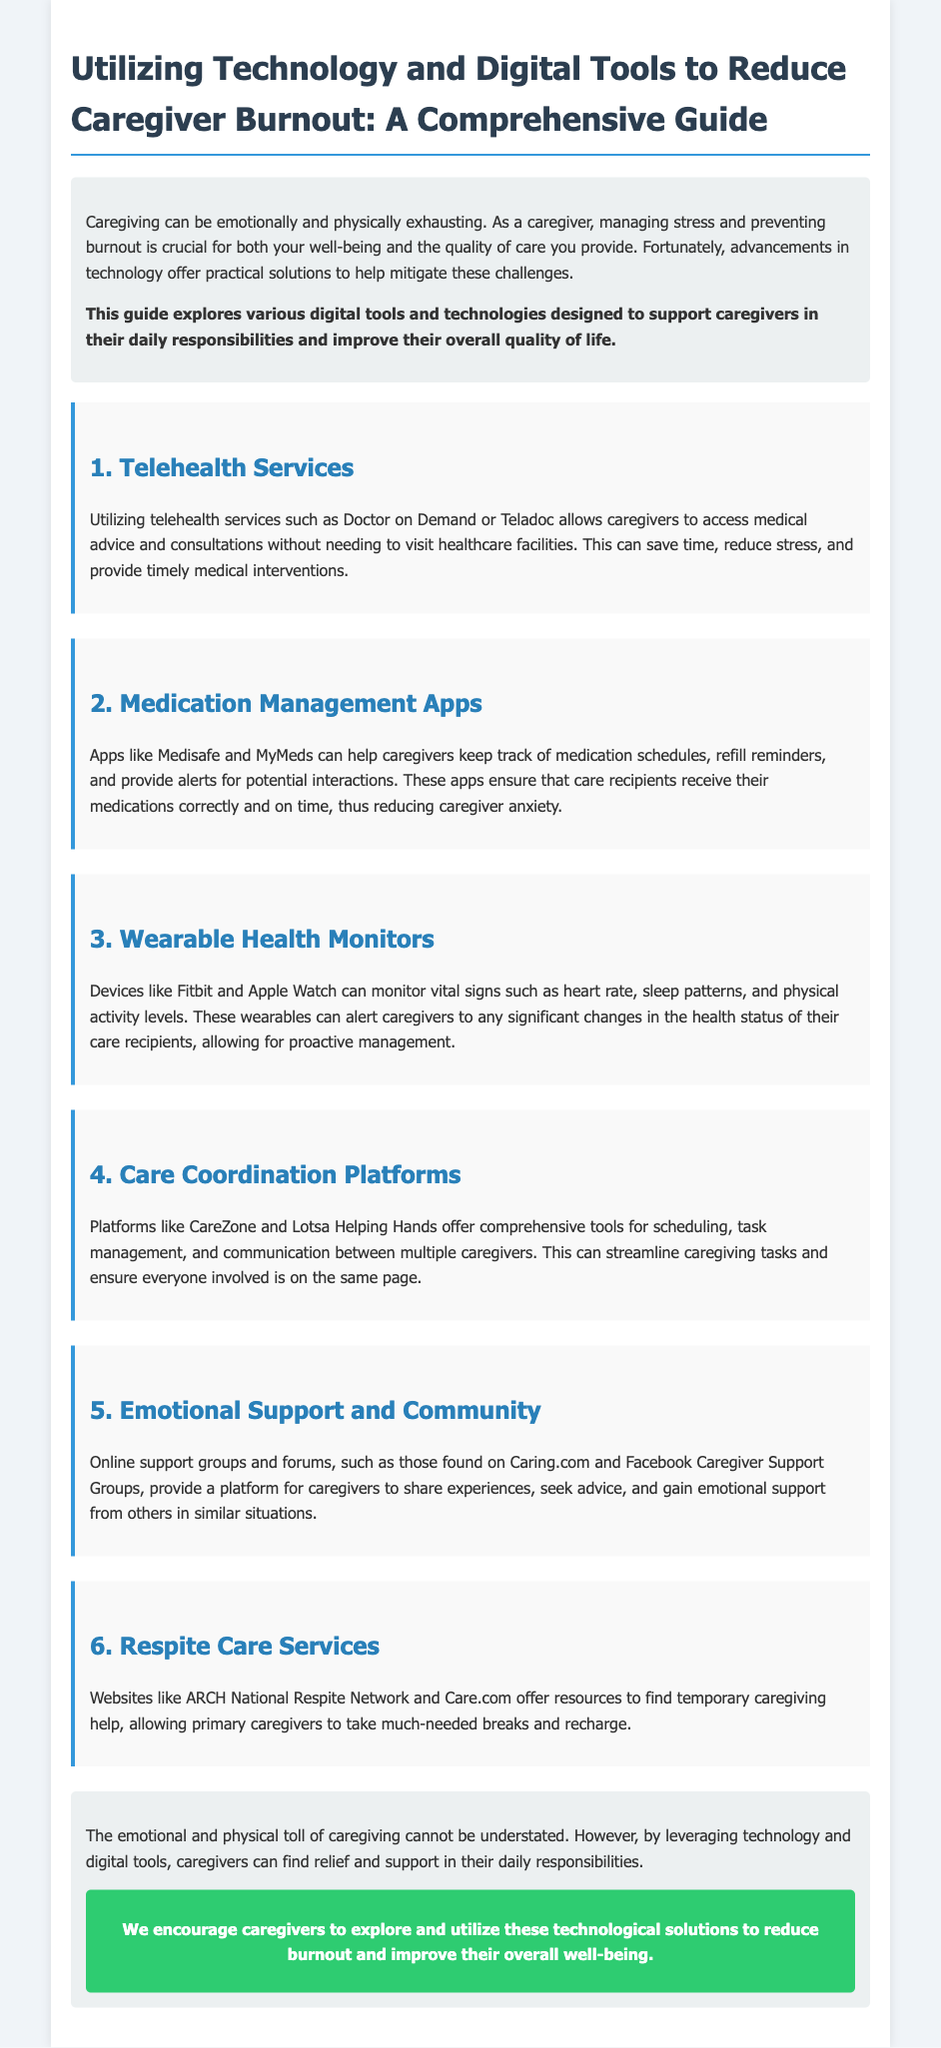What is the title of the document? The title is stated at the top of the document and summarizes the main theme, which is focused on technology and caregivers.
Answer: Utilizing Technology and Digital Tools to Reduce Caregiver Burnout: A Comprehensive Guide What are two examples of telehealth services mentioned? The document lists specific services that can be used for telehealth.
Answer: Doctor on Demand, Teladoc Which app is mentioned for medication management? The document specifically highlights an app that helps manage medication schedules for caregivers.
Answer: Medisafe What type of devices can monitor vital signs according to the document? The document refers to specific types of devices that caregivers can use for health monitoring.
Answer: Wearable Health Monitors What is one benefit of using care coordination platforms? The document details advantages of technology in caregiving, specifically for coordination among caregivers.
Answer: Streamline caregiving tasks What type of support can online forums provide to caregivers? The document discusses a specific benefit of online community resources for caregivers seeking help.
Answer: Emotional support What is the purpose of respite care services? The rationale behind this service is provided in the document, explaining its usefulness to caregivers.
Answer: Temporary caregiving help 